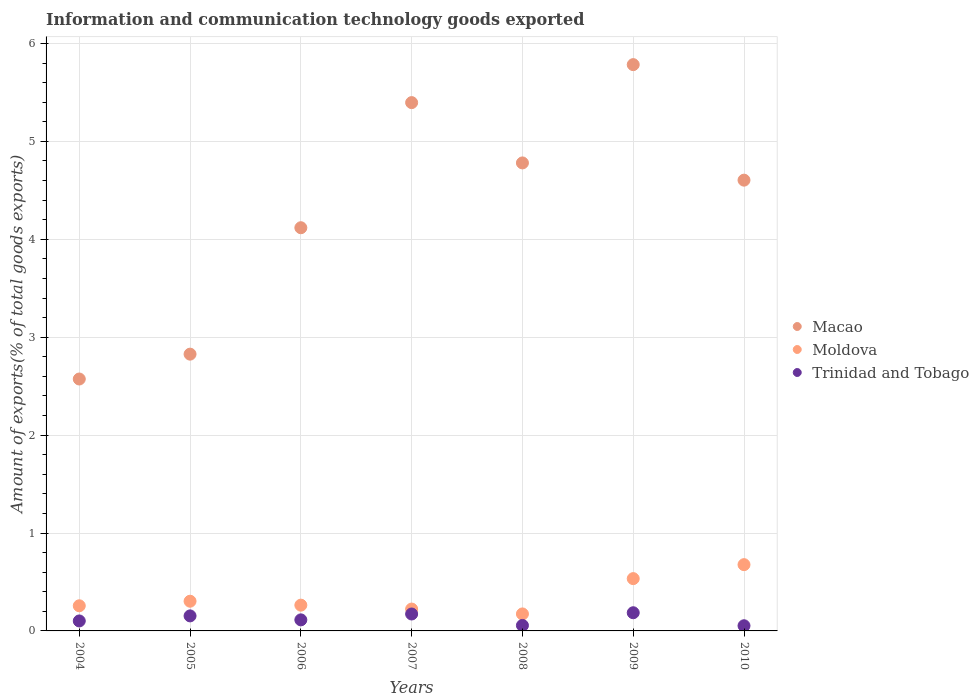What is the amount of goods exported in Macao in 2009?
Your response must be concise. 5.78. Across all years, what is the maximum amount of goods exported in Trinidad and Tobago?
Keep it short and to the point. 0.19. Across all years, what is the minimum amount of goods exported in Trinidad and Tobago?
Your answer should be very brief. 0.05. In which year was the amount of goods exported in Moldova maximum?
Ensure brevity in your answer.  2010. What is the total amount of goods exported in Moldova in the graph?
Ensure brevity in your answer.  2.43. What is the difference between the amount of goods exported in Macao in 2005 and that in 2009?
Provide a short and direct response. -2.96. What is the difference between the amount of goods exported in Macao in 2009 and the amount of goods exported in Moldova in 2008?
Ensure brevity in your answer.  5.61. What is the average amount of goods exported in Trinidad and Tobago per year?
Your answer should be compact. 0.12. In the year 2004, what is the difference between the amount of goods exported in Moldova and amount of goods exported in Trinidad and Tobago?
Your answer should be compact. 0.15. In how many years, is the amount of goods exported in Moldova greater than 2.6 %?
Make the answer very short. 0. What is the ratio of the amount of goods exported in Macao in 2007 to that in 2010?
Your answer should be very brief. 1.17. Is the amount of goods exported in Moldova in 2005 less than that in 2009?
Your answer should be very brief. Yes. Is the difference between the amount of goods exported in Moldova in 2004 and 2005 greater than the difference between the amount of goods exported in Trinidad and Tobago in 2004 and 2005?
Give a very brief answer. Yes. What is the difference between the highest and the second highest amount of goods exported in Trinidad and Tobago?
Your answer should be very brief. 0.01. What is the difference between the highest and the lowest amount of goods exported in Trinidad and Tobago?
Your answer should be compact. 0.13. In how many years, is the amount of goods exported in Macao greater than the average amount of goods exported in Macao taken over all years?
Make the answer very short. 4. Is the sum of the amount of goods exported in Trinidad and Tobago in 2005 and 2009 greater than the maximum amount of goods exported in Macao across all years?
Your response must be concise. No. Is it the case that in every year, the sum of the amount of goods exported in Macao and amount of goods exported in Moldova  is greater than the amount of goods exported in Trinidad and Tobago?
Make the answer very short. Yes. How many dotlines are there?
Make the answer very short. 3. How many years are there in the graph?
Keep it short and to the point. 7. Does the graph contain any zero values?
Keep it short and to the point. No. Does the graph contain grids?
Offer a very short reply. Yes. Where does the legend appear in the graph?
Make the answer very short. Center right. How are the legend labels stacked?
Provide a succinct answer. Vertical. What is the title of the graph?
Your response must be concise. Information and communication technology goods exported. Does "Colombia" appear as one of the legend labels in the graph?
Make the answer very short. No. What is the label or title of the X-axis?
Offer a terse response. Years. What is the label or title of the Y-axis?
Your answer should be very brief. Amount of exports(% of total goods exports). What is the Amount of exports(% of total goods exports) of Macao in 2004?
Keep it short and to the point. 2.57. What is the Amount of exports(% of total goods exports) of Moldova in 2004?
Provide a succinct answer. 0.26. What is the Amount of exports(% of total goods exports) in Trinidad and Tobago in 2004?
Keep it short and to the point. 0.1. What is the Amount of exports(% of total goods exports) of Macao in 2005?
Ensure brevity in your answer.  2.83. What is the Amount of exports(% of total goods exports) in Moldova in 2005?
Provide a succinct answer. 0.3. What is the Amount of exports(% of total goods exports) in Trinidad and Tobago in 2005?
Your answer should be very brief. 0.15. What is the Amount of exports(% of total goods exports) of Macao in 2006?
Your response must be concise. 4.12. What is the Amount of exports(% of total goods exports) in Moldova in 2006?
Provide a short and direct response. 0.26. What is the Amount of exports(% of total goods exports) in Trinidad and Tobago in 2006?
Give a very brief answer. 0.11. What is the Amount of exports(% of total goods exports) in Macao in 2007?
Provide a succinct answer. 5.4. What is the Amount of exports(% of total goods exports) in Moldova in 2007?
Ensure brevity in your answer.  0.22. What is the Amount of exports(% of total goods exports) of Trinidad and Tobago in 2007?
Offer a very short reply. 0.17. What is the Amount of exports(% of total goods exports) of Macao in 2008?
Give a very brief answer. 4.78. What is the Amount of exports(% of total goods exports) in Moldova in 2008?
Your answer should be very brief. 0.17. What is the Amount of exports(% of total goods exports) of Trinidad and Tobago in 2008?
Provide a short and direct response. 0.06. What is the Amount of exports(% of total goods exports) in Macao in 2009?
Your response must be concise. 5.78. What is the Amount of exports(% of total goods exports) in Moldova in 2009?
Your answer should be very brief. 0.53. What is the Amount of exports(% of total goods exports) in Trinidad and Tobago in 2009?
Provide a succinct answer. 0.19. What is the Amount of exports(% of total goods exports) of Macao in 2010?
Provide a short and direct response. 4.6. What is the Amount of exports(% of total goods exports) in Moldova in 2010?
Offer a very short reply. 0.68. What is the Amount of exports(% of total goods exports) in Trinidad and Tobago in 2010?
Give a very brief answer. 0.05. Across all years, what is the maximum Amount of exports(% of total goods exports) in Macao?
Make the answer very short. 5.78. Across all years, what is the maximum Amount of exports(% of total goods exports) of Moldova?
Your answer should be compact. 0.68. Across all years, what is the maximum Amount of exports(% of total goods exports) of Trinidad and Tobago?
Provide a short and direct response. 0.19. Across all years, what is the minimum Amount of exports(% of total goods exports) in Macao?
Make the answer very short. 2.57. Across all years, what is the minimum Amount of exports(% of total goods exports) of Moldova?
Provide a succinct answer. 0.17. Across all years, what is the minimum Amount of exports(% of total goods exports) in Trinidad and Tobago?
Make the answer very short. 0.05. What is the total Amount of exports(% of total goods exports) of Macao in the graph?
Provide a short and direct response. 30.08. What is the total Amount of exports(% of total goods exports) of Moldova in the graph?
Offer a terse response. 2.43. What is the total Amount of exports(% of total goods exports) of Trinidad and Tobago in the graph?
Your answer should be very brief. 0.84. What is the difference between the Amount of exports(% of total goods exports) of Macao in 2004 and that in 2005?
Keep it short and to the point. -0.25. What is the difference between the Amount of exports(% of total goods exports) in Moldova in 2004 and that in 2005?
Keep it short and to the point. -0.05. What is the difference between the Amount of exports(% of total goods exports) in Trinidad and Tobago in 2004 and that in 2005?
Your answer should be compact. -0.05. What is the difference between the Amount of exports(% of total goods exports) in Macao in 2004 and that in 2006?
Ensure brevity in your answer.  -1.55. What is the difference between the Amount of exports(% of total goods exports) in Moldova in 2004 and that in 2006?
Give a very brief answer. -0.01. What is the difference between the Amount of exports(% of total goods exports) of Trinidad and Tobago in 2004 and that in 2006?
Your answer should be very brief. -0.01. What is the difference between the Amount of exports(% of total goods exports) in Macao in 2004 and that in 2007?
Keep it short and to the point. -2.82. What is the difference between the Amount of exports(% of total goods exports) of Moldova in 2004 and that in 2007?
Keep it short and to the point. 0.03. What is the difference between the Amount of exports(% of total goods exports) of Trinidad and Tobago in 2004 and that in 2007?
Offer a very short reply. -0.07. What is the difference between the Amount of exports(% of total goods exports) of Macao in 2004 and that in 2008?
Give a very brief answer. -2.21. What is the difference between the Amount of exports(% of total goods exports) in Moldova in 2004 and that in 2008?
Your response must be concise. 0.08. What is the difference between the Amount of exports(% of total goods exports) of Trinidad and Tobago in 2004 and that in 2008?
Your answer should be very brief. 0.05. What is the difference between the Amount of exports(% of total goods exports) of Macao in 2004 and that in 2009?
Your response must be concise. -3.21. What is the difference between the Amount of exports(% of total goods exports) of Moldova in 2004 and that in 2009?
Ensure brevity in your answer.  -0.28. What is the difference between the Amount of exports(% of total goods exports) in Trinidad and Tobago in 2004 and that in 2009?
Your answer should be very brief. -0.08. What is the difference between the Amount of exports(% of total goods exports) in Macao in 2004 and that in 2010?
Offer a terse response. -2.03. What is the difference between the Amount of exports(% of total goods exports) in Moldova in 2004 and that in 2010?
Your answer should be very brief. -0.42. What is the difference between the Amount of exports(% of total goods exports) of Trinidad and Tobago in 2004 and that in 2010?
Make the answer very short. 0.05. What is the difference between the Amount of exports(% of total goods exports) of Macao in 2005 and that in 2006?
Your response must be concise. -1.29. What is the difference between the Amount of exports(% of total goods exports) of Moldova in 2005 and that in 2006?
Keep it short and to the point. 0.04. What is the difference between the Amount of exports(% of total goods exports) of Trinidad and Tobago in 2005 and that in 2006?
Offer a terse response. 0.04. What is the difference between the Amount of exports(% of total goods exports) of Macao in 2005 and that in 2007?
Provide a succinct answer. -2.57. What is the difference between the Amount of exports(% of total goods exports) in Moldova in 2005 and that in 2007?
Your answer should be very brief. 0.08. What is the difference between the Amount of exports(% of total goods exports) in Trinidad and Tobago in 2005 and that in 2007?
Your answer should be very brief. -0.02. What is the difference between the Amount of exports(% of total goods exports) in Macao in 2005 and that in 2008?
Offer a very short reply. -1.95. What is the difference between the Amount of exports(% of total goods exports) of Moldova in 2005 and that in 2008?
Offer a terse response. 0.13. What is the difference between the Amount of exports(% of total goods exports) in Trinidad and Tobago in 2005 and that in 2008?
Make the answer very short. 0.1. What is the difference between the Amount of exports(% of total goods exports) of Macao in 2005 and that in 2009?
Give a very brief answer. -2.96. What is the difference between the Amount of exports(% of total goods exports) in Moldova in 2005 and that in 2009?
Keep it short and to the point. -0.23. What is the difference between the Amount of exports(% of total goods exports) in Trinidad and Tobago in 2005 and that in 2009?
Offer a terse response. -0.03. What is the difference between the Amount of exports(% of total goods exports) in Macao in 2005 and that in 2010?
Your response must be concise. -1.78. What is the difference between the Amount of exports(% of total goods exports) of Moldova in 2005 and that in 2010?
Provide a succinct answer. -0.37. What is the difference between the Amount of exports(% of total goods exports) in Trinidad and Tobago in 2005 and that in 2010?
Provide a succinct answer. 0.1. What is the difference between the Amount of exports(% of total goods exports) in Macao in 2006 and that in 2007?
Your response must be concise. -1.28. What is the difference between the Amount of exports(% of total goods exports) of Moldova in 2006 and that in 2007?
Ensure brevity in your answer.  0.04. What is the difference between the Amount of exports(% of total goods exports) of Trinidad and Tobago in 2006 and that in 2007?
Your response must be concise. -0.06. What is the difference between the Amount of exports(% of total goods exports) in Macao in 2006 and that in 2008?
Provide a succinct answer. -0.66. What is the difference between the Amount of exports(% of total goods exports) in Moldova in 2006 and that in 2008?
Keep it short and to the point. 0.09. What is the difference between the Amount of exports(% of total goods exports) in Trinidad and Tobago in 2006 and that in 2008?
Your answer should be compact. 0.06. What is the difference between the Amount of exports(% of total goods exports) in Macao in 2006 and that in 2009?
Your answer should be compact. -1.67. What is the difference between the Amount of exports(% of total goods exports) of Moldova in 2006 and that in 2009?
Make the answer very short. -0.27. What is the difference between the Amount of exports(% of total goods exports) of Trinidad and Tobago in 2006 and that in 2009?
Ensure brevity in your answer.  -0.07. What is the difference between the Amount of exports(% of total goods exports) of Macao in 2006 and that in 2010?
Your response must be concise. -0.49. What is the difference between the Amount of exports(% of total goods exports) in Moldova in 2006 and that in 2010?
Your answer should be very brief. -0.41. What is the difference between the Amount of exports(% of total goods exports) of Trinidad and Tobago in 2006 and that in 2010?
Make the answer very short. 0.06. What is the difference between the Amount of exports(% of total goods exports) in Macao in 2007 and that in 2008?
Keep it short and to the point. 0.62. What is the difference between the Amount of exports(% of total goods exports) in Moldova in 2007 and that in 2008?
Make the answer very short. 0.05. What is the difference between the Amount of exports(% of total goods exports) of Trinidad and Tobago in 2007 and that in 2008?
Make the answer very short. 0.12. What is the difference between the Amount of exports(% of total goods exports) of Macao in 2007 and that in 2009?
Give a very brief answer. -0.39. What is the difference between the Amount of exports(% of total goods exports) of Moldova in 2007 and that in 2009?
Offer a terse response. -0.31. What is the difference between the Amount of exports(% of total goods exports) in Trinidad and Tobago in 2007 and that in 2009?
Offer a terse response. -0.01. What is the difference between the Amount of exports(% of total goods exports) in Macao in 2007 and that in 2010?
Ensure brevity in your answer.  0.79. What is the difference between the Amount of exports(% of total goods exports) of Moldova in 2007 and that in 2010?
Provide a short and direct response. -0.45. What is the difference between the Amount of exports(% of total goods exports) in Trinidad and Tobago in 2007 and that in 2010?
Offer a very short reply. 0.12. What is the difference between the Amount of exports(% of total goods exports) in Macao in 2008 and that in 2009?
Ensure brevity in your answer.  -1. What is the difference between the Amount of exports(% of total goods exports) of Moldova in 2008 and that in 2009?
Ensure brevity in your answer.  -0.36. What is the difference between the Amount of exports(% of total goods exports) of Trinidad and Tobago in 2008 and that in 2009?
Make the answer very short. -0.13. What is the difference between the Amount of exports(% of total goods exports) of Macao in 2008 and that in 2010?
Give a very brief answer. 0.18. What is the difference between the Amount of exports(% of total goods exports) in Moldova in 2008 and that in 2010?
Give a very brief answer. -0.5. What is the difference between the Amount of exports(% of total goods exports) of Trinidad and Tobago in 2008 and that in 2010?
Offer a very short reply. 0. What is the difference between the Amount of exports(% of total goods exports) of Macao in 2009 and that in 2010?
Offer a terse response. 1.18. What is the difference between the Amount of exports(% of total goods exports) of Moldova in 2009 and that in 2010?
Your answer should be very brief. -0.14. What is the difference between the Amount of exports(% of total goods exports) in Trinidad and Tobago in 2009 and that in 2010?
Provide a short and direct response. 0.13. What is the difference between the Amount of exports(% of total goods exports) of Macao in 2004 and the Amount of exports(% of total goods exports) of Moldova in 2005?
Keep it short and to the point. 2.27. What is the difference between the Amount of exports(% of total goods exports) in Macao in 2004 and the Amount of exports(% of total goods exports) in Trinidad and Tobago in 2005?
Your response must be concise. 2.42. What is the difference between the Amount of exports(% of total goods exports) in Moldova in 2004 and the Amount of exports(% of total goods exports) in Trinidad and Tobago in 2005?
Provide a succinct answer. 0.1. What is the difference between the Amount of exports(% of total goods exports) in Macao in 2004 and the Amount of exports(% of total goods exports) in Moldova in 2006?
Your answer should be very brief. 2.31. What is the difference between the Amount of exports(% of total goods exports) of Macao in 2004 and the Amount of exports(% of total goods exports) of Trinidad and Tobago in 2006?
Ensure brevity in your answer.  2.46. What is the difference between the Amount of exports(% of total goods exports) of Moldova in 2004 and the Amount of exports(% of total goods exports) of Trinidad and Tobago in 2006?
Provide a short and direct response. 0.14. What is the difference between the Amount of exports(% of total goods exports) of Macao in 2004 and the Amount of exports(% of total goods exports) of Moldova in 2007?
Give a very brief answer. 2.35. What is the difference between the Amount of exports(% of total goods exports) in Macao in 2004 and the Amount of exports(% of total goods exports) in Trinidad and Tobago in 2007?
Your answer should be compact. 2.4. What is the difference between the Amount of exports(% of total goods exports) in Moldova in 2004 and the Amount of exports(% of total goods exports) in Trinidad and Tobago in 2007?
Your answer should be compact. 0.08. What is the difference between the Amount of exports(% of total goods exports) in Macao in 2004 and the Amount of exports(% of total goods exports) in Moldova in 2008?
Keep it short and to the point. 2.4. What is the difference between the Amount of exports(% of total goods exports) in Macao in 2004 and the Amount of exports(% of total goods exports) in Trinidad and Tobago in 2008?
Make the answer very short. 2.52. What is the difference between the Amount of exports(% of total goods exports) of Moldova in 2004 and the Amount of exports(% of total goods exports) of Trinidad and Tobago in 2008?
Provide a short and direct response. 0.2. What is the difference between the Amount of exports(% of total goods exports) in Macao in 2004 and the Amount of exports(% of total goods exports) in Moldova in 2009?
Offer a very short reply. 2.04. What is the difference between the Amount of exports(% of total goods exports) of Macao in 2004 and the Amount of exports(% of total goods exports) of Trinidad and Tobago in 2009?
Make the answer very short. 2.39. What is the difference between the Amount of exports(% of total goods exports) of Moldova in 2004 and the Amount of exports(% of total goods exports) of Trinidad and Tobago in 2009?
Offer a very short reply. 0.07. What is the difference between the Amount of exports(% of total goods exports) of Macao in 2004 and the Amount of exports(% of total goods exports) of Moldova in 2010?
Ensure brevity in your answer.  1.9. What is the difference between the Amount of exports(% of total goods exports) in Macao in 2004 and the Amount of exports(% of total goods exports) in Trinidad and Tobago in 2010?
Your answer should be very brief. 2.52. What is the difference between the Amount of exports(% of total goods exports) in Moldova in 2004 and the Amount of exports(% of total goods exports) in Trinidad and Tobago in 2010?
Offer a terse response. 0.2. What is the difference between the Amount of exports(% of total goods exports) of Macao in 2005 and the Amount of exports(% of total goods exports) of Moldova in 2006?
Make the answer very short. 2.56. What is the difference between the Amount of exports(% of total goods exports) of Macao in 2005 and the Amount of exports(% of total goods exports) of Trinidad and Tobago in 2006?
Keep it short and to the point. 2.71. What is the difference between the Amount of exports(% of total goods exports) in Moldova in 2005 and the Amount of exports(% of total goods exports) in Trinidad and Tobago in 2006?
Make the answer very short. 0.19. What is the difference between the Amount of exports(% of total goods exports) of Macao in 2005 and the Amount of exports(% of total goods exports) of Moldova in 2007?
Keep it short and to the point. 2.6. What is the difference between the Amount of exports(% of total goods exports) of Macao in 2005 and the Amount of exports(% of total goods exports) of Trinidad and Tobago in 2007?
Offer a terse response. 2.65. What is the difference between the Amount of exports(% of total goods exports) in Moldova in 2005 and the Amount of exports(% of total goods exports) in Trinidad and Tobago in 2007?
Ensure brevity in your answer.  0.13. What is the difference between the Amount of exports(% of total goods exports) of Macao in 2005 and the Amount of exports(% of total goods exports) of Moldova in 2008?
Ensure brevity in your answer.  2.65. What is the difference between the Amount of exports(% of total goods exports) in Macao in 2005 and the Amount of exports(% of total goods exports) in Trinidad and Tobago in 2008?
Your response must be concise. 2.77. What is the difference between the Amount of exports(% of total goods exports) in Moldova in 2005 and the Amount of exports(% of total goods exports) in Trinidad and Tobago in 2008?
Provide a short and direct response. 0.25. What is the difference between the Amount of exports(% of total goods exports) in Macao in 2005 and the Amount of exports(% of total goods exports) in Moldova in 2009?
Offer a very short reply. 2.29. What is the difference between the Amount of exports(% of total goods exports) in Macao in 2005 and the Amount of exports(% of total goods exports) in Trinidad and Tobago in 2009?
Your answer should be very brief. 2.64. What is the difference between the Amount of exports(% of total goods exports) in Moldova in 2005 and the Amount of exports(% of total goods exports) in Trinidad and Tobago in 2009?
Offer a very short reply. 0.12. What is the difference between the Amount of exports(% of total goods exports) in Macao in 2005 and the Amount of exports(% of total goods exports) in Moldova in 2010?
Your answer should be compact. 2.15. What is the difference between the Amount of exports(% of total goods exports) in Macao in 2005 and the Amount of exports(% of total goods exports) in Trinidad and Tobago in 2010?
Give a very brief answer. 2.77. What is the difference between the Amount of exports(% of total goods exports) in Moldova in 2005 and the Amount of exports(% of total goods exports) in Trinidad and Tobago in 2010?
Provide a succinct answer. 0.25. What is the difference between the Amount of exports(% of total goods exports) of Macao in 2006 and the Amount of exports(% of total goods exports) of Moldova in 2007?
Make the answer very short. 3.89. What is the difference between the Amount of exports(% of total goods exports) of Macao in 2006 and the Amount of exports(% of total goods exports) of Trinidad and Tobago in 2007?
Your response must be concise. 3.95. What is the difference between the Amount of exports(% of total goods exports) of Moldova in 2006 and the Amount of exports(% of total goods exports) of Trinidad and Tobago in 2007?
Your response must be concise. 0.09. What is the difference between the Amount of exports(% of total goods exports) in Macao in 2006 and the Amount of exports(% of total goods exports) in Moldova in 2008?
Provide a short and direct response. 3.94. What is the difference between the Amount of exports(% of total goods exports) in Macao in 2006 and the Amount of exports(% of total goods exports) in Trinidad and Tobago in 2008?
Your answer should be very brief. 4.06. What is the difference between the Amount of exports(% of total goods exports) in Moldova in 2006 and the Amount of exports(% of total goods exports) in Trinidad and Tobago in 2008?
Your response must be concise. 0.21. What is the difference between the Amount of exports(% of total goods exports) of Macao in 2006 and the Amount of exports(% of total goods exports) of Moldova in 2009?
Offer a terse response. 3.58. What is the difference between the Amount of exports(% of total goods exports) of Macao in 2006 and the Amount of exports(% of total goods exports) of Trinidad and Tobago in 2009?
Keep it short and to the point. 3.93. What is the difference between the Amount of exports(% of total goods exports) of Moldova in 2006 and the Amount of exports(% of total goods exports) of Trinidad and Tobago in 2009?
Ensure brevity in your answer.  0.08. What is the difference between the Amount of exports(% of total goods exports) in Macao in 2006 and the Amount of exports(% of total goods exports) in Moldova in 2010?
Your answer should be compact. 3.44. What is the difference between the Amount of exports(% of total goods exports) in Macao in 2006 and the Amount of exports(% of total goods exports) in Trinidad and Tobago in 2010?
Make the answer very short. 4.07. What is the difference between the Amount of exports(% of total goods exports) in Moldova in 2006 and the Amount of exports(% of total goods exports) in Trinidad and Tobago in 2010?
Your answer should be compact. 0.21. What is the difference between the Amount of exports(% of total goods exports) of Macao in 2007 and the Amount of exports(% of total goods exports) of Moldova in 2008?
Ensure brevity in your answer.  5.22. What is the difference between the Amount of exports(% of total goods exports) of Macao in 2007 and the Amount of exports(% of total goods exports) of Trinidad and Tobago in 2008?
Provide a short and direct response. 5.34. What is the difference between the Amount of exports(% of total goods exports) in Moldova in 2007 and the Amount of exports(% of total goods exports) in Trinidad and Tobago in 2008?
Give a very brief answer. 0.17. What is the difference between the Amount of exports(% of total goods exports) of Macao in 2007 and the Amount of exports(% of total goods exports) of Moldova in 2009?
Make the answer very short. 4.86. What is the difference between the Amount of exports(% of total goods exports) in Macao in 2007 and the Amount of exports(% of total goods exports) in Trinidad and Tobago in 2009?
Provide a short and direct response. 5.21. What is the difference between the Amount of exports(% of total goods exports) of Moldova in 2007 and the Amount of exports(% of total goods exports) of Trinidad and Tobago in 2009?
Give a very brief answer. 0.04. What is the difference between the Amount of exports(% of total goods exports) of Macao in 2007 and the Amount of exports(% of total goods exports) of Moldova in 2010?
Keep it short and to the point. 4.72. What is the difference between the Amount of exports(% of total goods exports) of Macao in 2007 and the Amount of exports(% of total goods exports) of Trinidad and Tobago in 2010?
Your response must be concise. 5.34. What is the difference between the Amount of exports(% of total goods exports) of Moldova in 2007 and the Amount of exports(% of total goods exports) of Trinidad and Tobago in 2010?
Your answer should be compact. 0.17. What is the difference between the Amount of exports(% of total goods exports) of Macao in 2008 and the Amount of exports(% of total goods exports) of Moldova in 2009?
Provide a succinct answer. 4.25. What is the difference between the Amount of exports(% of total goods exports) in Macao in 2008 and the Amount of exports(% of total goods exports) in Trinidad and Tobago in 2009?
Give a very brief answer. 4.59. What is the difference between the Amount of exports(% of total goods exports) in Moldova in 2008 and the Amount of exports(% of total goods exports) in Trinidad and Tobago in 2009?
Give a very brief answer. -0.01. What is the difference between the Amount of exports(% of total goods exports) in Macao in 2008 and the Amount of exports(% of total goods exports) in Moldova in 2010?
Your answer should be compact. 4.1. What is the difference between the Amount of exports(% of total goods exports) of Macao in 2008 and the Amount of exports(% of total goods exports) of Trinidad and Tobago in 2010?
Your answer should be very brief. 4.73. What is the difference between the Amount of exports(% of total goods exports) in Moldova in 2008 and the Amount of exports(% of total goods exports) in Trinidad and Tobago in 2010?
Your answer should be very brief. 0.12. What is the difference between the Amount of exports(% of total goods exports) of Macao in 2009 and the Amount of exports(% of total goods exports) of Moldova in 2010?
Keep it short and to the point. 5.11. What is the difference between the Amount of exports(% of total goods exports) in Macao in 2009 and the Amount of exports(% of total goods exports) in Trinidad and Tobago in 2010?
Keep it short and to the point. 5.73. What is the difference between the Amount of exports(% of total goods exports) in Moldova in 2009 and the Amount of exports(% of total goods exports) in Trinidad and Tobago in 2010?
Give a very brief answer. 0.48. What is the average Amount of exports(% of total goods exports) of Macao per year?
Your answer should be very brief. 4.3. What is the average Amount of exports(% of total goods exports) in Moldova per year?
Make the answer very short. 0.35. What is the average Amount of exports(% of total goods exports) in Trinidad and Tobago per year?
Offer a terse response. 0.12. In the year 2004, what is the difference between the Amount of exports(% of total goods exports) in Macao and Amount of exports(% of total goods exports) in Moldova?
Your response must be concise. 2.32. In the year 2004, what is the difference between the Amount of exports(% of total goods exports) of Macao and Amount of exports(% of total goods exports) of Trinidad and Tobago?
Offer a very short reply. 2.47. In the year 2004, what is the difference between the Amount of exports(% of total goods exports) in Moldova and Amount of exports(% of total goods exports) in Trinidad and Tobago?
Make the answer very short. 0.15. In the year 2005, what is the difference between the Amount of exports(% of total goods exports) of Macao and Amount of exports(% of total goods exports) of Moldova?
Give a very brief answer. 2.52. In the year 2005, what is the difference between the Amount of exports(% of total goods exports) of Macao and Amount of exports(% of total goods exports) of Trinidad and Tobago?
Your answer should be compact. 2.67. In the year 2005, what is the difference between the Amount of exports(% of total goods exports) in Moldova and Amount of exports(% of total goods exports) in Trinidad and Tobago?
Provide a succinct answer. 0.15. In the year 2006, what is the difference between the Amount of exports(% of total goods exports) of Macao and Amount of exports(% of total goods exports) of Moldova?
Keep it short and to the point. 3.85. In the year 2006, what is the difference between the Amount of exports(% of total goods exports) in Macao and Amount of exports(% of total goods exports) in Trinidad and Tobago?
Your response must be concise. 4.01. In the year 2006, what is the difference between the Amount of exports(% of total goods exports) in Moldova and Amount of exports(% of total goods exports) in Trinidad and Tobago?
Ensure brevity in your answer.  0.15. In the year 2007, what is the difference between the Amount of exports(% of total goods exports) of Macao and Amount of exports(% of total goods exports) of Moldova?
Your answer should be very brief. 5.17. In the year 2007, what is the difference between the Amount of exports(% of total goods exports) in Macao and Amount of exports(% of total goods exports) in Trinidad and Tobago?
Offer a terse response. 5.22. In the year 2007, what is the difference between the Amount of exports(% of total goods exports) of Moldova and Amount of exports(% of total goods exports) of Trinidad and Tobago?
Give a very brief answer. 0.05. In the year 2008, what is the difference between the Amount of exports(% of total goods exports) of Macao and Amount of exports(% of total goods exports) of Moldova?
Make the answer very short. 4.61. In the year 2008, what is the difference between the Amount of exports(% of total goods exports) of Macao and Amount of exports(% of total goods exports) of Trinidad and Tobago?
Offer a very short reply. 4.72. In the year 2008, what is the difference between the Amount of exports(% of total goods exports) in Moldova and Amount of exports(% of total goods exports) in Trinidad and Tobago?
Provide a succinct answer. 0.12. In the year 2009, what is the difference between the Amount of exports(% of total goods exports) in Macao and Amount of exports(% of total goods exports) in Moldova?
Give a very brief answer. 5.25. In the year 2009, what is the difference between the Amount of exports(% of total goods exports) of Macao and Amount of exports(% of total goods exports) of Trinidad and Tobago?
Provide a succinct answer. 5.6. In the year 2009, what is the difference between the Amount of exports(% of total goods exports) in Moldova and Amount of exports(% of total goods exports) in Trinidad and Tobago?
Your answer should be very brief. 0.35. In the year 2010, what is the difference between the Amount of exports(% of total goods exports) in Macao and Amount of exports(% of total goods exports) in Moldova?
Provide a short and direct response. 3.93. In the year 2010, what is the difference between the Amount of exports(% of total goods exports) in Macao and Amount of exports(% of total goods exports) in Trinidad and Tobago?
Keep it short and to the point. 4.55. In the year 2010, what is the difference between the Amount of exports(% of total goods exports) of Moldova and Amount of exports(% of total goods exports) of Trinidad and Tobago?
Make the answer very short. 0.62. What is the ratio of the Amount of exports(% of total goods exports) of Macao in 2004 to that in 2005?
Keep it short and to the point. 0.91. What is the ratio of the Amount of exports(% of total goods exports) in Moldova in 2004 to that in 2005?
Offer a terse response. 0.85. What is the ratio of the Amount of exports(% of total goods exports) of Trinidad and Tobago in 2004 to that in 2005?
Provide a short and direct response. 0.66. What is the ratio of the Amount of exports(% of total goods exports) in Macao in 2004 to that in 2006?
Keep it short and to the point. 0.62. What is the ratio of the Amount of exports(% of total goods exports) of Moldova in 2004 to that in 2006?
Your answer should be compact. 0.98. What is the ratio of the Amount of exports(% of total goods exports) of Trinidad and Tobago in 2004 to that in 2006?
Ensure brevity in your answer.  0.9. What is the ratio of the Amount of exports(% of total goods exports) of Macao in 2004 to that in 2007?
Your response must be concise. 0.48. What is the ratio of the Amount of exports(% of total goods exports) of Moldova in 2004 to that in 2007?
Provide a succinct answer. 1.15. What is the ratio of the Amount of exports(% of total goods exports) of Trinidad and Tobago in 2004 to that in 2007?
Keep it short and to the point. 0.59. What is the ratio of the Amount of exports(% of total goods exports) in Macao in 2004 to that in 2008?
Your answer should be compact. 0.54. What is the ratio of the Amount of exports(% of total goods exports) in Moldova in 2004 to that in 2008?
Provide a succinct answer. 1.48. What is the ratio of the Amount of exports(% of total goods exports) of Trinidad and Tobago in 2004 to that in 2008?
Your answer should be compact. 1.82. What is the ratio of the Amount of exports(% of total goods exports) of Macao in 2004 to that in 2009?
Provide a short and direct response. 0.44. What is the ratio of the Amount of exports(% of total goods exports) in Moldova in 2004 to that in 2009?
Offer a terse response. 0.48. What is the ratio of the Amount of exports(% of total goods exports) in Trinidad and Tobago in 2004 to that in 2009?
Make the answer very short. 0.55. What is the ratio of the Amount of exports(% of total goods exports) in Macao in 2004 to that in 2010?
Offer a very short reply. 0.56. What is the ratio of the Amount of exports(% of total goods exports) of Moldova in 2004 to that in 2010?
Give a very brief answer. 0.38. What is the ratio of the Amount of exports(% of total goods exports) in Trinidad and Tobago in 2004 to that in 2010?
Your response must be concise. 1.93. What is the ratio of the Amount of exports(% of total goods exports) of Macao in 2005 to that in 2006?
Provide a short and direct response. 0.69. What is the ratio of the Amount of exports(% of total goods exports) of Moldova in 2005 to that in 2006?
Provide a short and direct response. 1.15. What is the ratio of the Amount of exports(% of total goods exports) of Trinidad and Tobago in 2005 to that in 2006?
Give a very brief answer. 1.36. What is the ratio of the Amount of exports(% of total goods exports) of Macao in 2005 to that in 2007?
Your response must be concise. 0.52. What is the ratio of the Amount of exports(% of total goods exports) of Moldova in 2005 to that in 2007?
Your answer should be very brief. 1.36. What is the ratio of the Amount of exports(% of total goods exports) in Trinidad and Tobago in 2005 to that in 2007?
Ensure brevity in your answer.  0.89. What is the ratio of the Amount of exports(% of total goods exports) in Macao in 2005 to that in 2008?
Offer a terse response. 0.59. What is the ratio of the Amount of exports(% of total goods exports) in Moldova in 2005 to that in 2008?
Keep it short and to the point. 1.75. What is the ratio of the Amount of exports(% of total goods exports) of Trinidad and Tobago in 2005 to that in 2008?
Offer a terse response. 2.74. What is the ratio of the Amount of exports(% of total goods exports) of Macao in 2005 to that in 2009?
Your response must be concise. 0.49. What is the ratio of the Amount of exports(% of total goods exports) in Moldova in 2005 to that in 2009?
Provide a succinct answer. 0.57. What is the ratio of the Amount of exports(% of total goods exports) of Trinidad and Tobago in 2005 to that in 2009?
Your response must be concise. 0.83. What is the ratio of the Amount of exports(% of total goods exports) in Macao in 2005 to that in 2010?
Provide a short and direct response. 0.61. What is the ratio of the Amount of exports(% of total goods exports) in Moldova in 2005 to that in 2010?
Give a very brief answer. 0.45. What is the ratio of the Amount of exports(% of total goods exports) in Trinidad and Tobago in 2005 to that in 2010?
Keep it short and to the point. 2.91. What is the ratio of the Amount of exports(% of total goods exports) of Macao in 2006 to that in 2007?
Provide a succinct answer. 0.76. What is the ratio of the Amount of exports(% of total goods exports) in Moldova in 2006 to that in 2007?
Your answer should be very brief. 1.18. What is the ratio of the Amount of exports(% of total goods exports) in Trinidad and Tobago in 2006 to that in 2007?
Give a very brief answer. 0.65. What is the ratio of the Amount of exports(% of total goods exports) in Macao in 2006 to that in 2008?
Provide a short and direct response. 0.86. What is the ratio of the Amount of exports(% of total goods exports) in Moldova in 2006 to that in 2008?
Give a very brief answer. 1.52. What is the ratio of the Amount of exports(% of total goods exports) of Trinidad and Tobago in 2006 to that in 2008?
Ensure brevity in your answer.  2.02. What is the ratio of the Amount of exports(% of total goods exports) of Macao in 2006 to that in 2009?
Make the answer very short. 0.71. What is the ratio of the Amount of exports(% of total goods exports) in Moldova in 2006 to that in 2009?
Provide a succinct answer. 0.49. What is the ratio of the Amount of exports(% of total goods exports) in Trinidad and Tobago in 2006 to that in 2009?
Ensure brevity in your answer.  0.61. What is the ratio of the Amount of exports(% of total goods exports) in Macao in 2006 to that in 2010?
Give a very brief answer. 0.89. What is the ratio of the Amount of exports(% of total goods exports) of Moldova in 2006 to that in 2010?
Provide a short and direct response. 0.39. What is the ratio of the Amount of exports(% of total goods exports) of Trinidad and Tobago in 2006 to that in 2010?
Your answer should be very brief. 2.14. What is the ratio of the Amount of exports(% of total goods exports) in Macao in 2007 to that in 2008?
Ensure brevity in your answer.  1.13. What is the ratio of the Amount of exports(% of total goods exports) in Moldova in 2007 to that in 2008?
Provide a succinct answer. 1.29. What is the ratio of the Amount of exports(% of total goods exports) of Trinidad and Tobago in 2007 to that in 2008?
Your response must be concise. 3.09. What is the ratio of the Amount of exports(% of total goods exports) in Macao in 2007 to that in 2009?
Make the answer very short. 0.93. What is the ratio of the Amount of exports(% of total goods exports) of Moldova in 2007 to that in 2009?
Offer a very short reply. 0.42. What is the ratio of the Amount of exports(% of total goods exports) in Macao in 2007 to that in 2010?
Your response must be concise. 1.17. What is the ratio of the Amount of exports(% of total goods exports) of Moldova in 2007 to that in 2010?
Offer a terse response. 0.33. What is the ratio of the Amount of exports(% of total goods exports) of Trinidad and Tobago in 2007 to that in 2010?
Make the answer very short. 3.28. What is the ratio of the Amount of exports(% of total goods exports) of Macao in 2008 to that in 2009?
Your answer should be very brief. 0.83. What is the ratio of the Amount of exports(% of total goods exports) of Moldova in 2008 to that in 2009?
Keep it short and to the point. 0.32. What is the ratio of the Amount of exports(% of total goods exports) of Trinidad and Tobago in 2008 to that in 2009?
Make the answer very short. 0.3. What is the ratio of the Amount of exports(% of total goods exports) in Macao in 2008 to that in 2010?
Your answer should be compact. 1.04. What is the ratio of the Amount of exports(% of total goods exports) in Moldova in 2008 to that in 2010?
Provide a short and direct response. 0.26. What is the ratio of the Amount of exports(% of total goods exports) in Trinidad and Tobago in 2008 to that in 2010?
Keep it short and to the point. 1.06. What is the ratio of the Amount of exports(% of total goods exports) of Macao in 2009 to that in 2010?
Offer a very short reply. 1.26. What is the ratio of the Amount of exports(% of total goods exports) of Moldova in 2009 to that in 2010?
Make the answer very short. 0.79. What is the ratio of the Amount of exports(% of total goods exports) in Trinidad and Tobago in 2009 to that in 2010?
Your answer should be very brief. 3.52. What is the difference between the highest and the second highest Amount of exports(% of total goods exports) in Macao?
Your answer should be compact. 0.39. What is the difference between the highest and the second highest Amount of exports(% of total goods exports) of Moldova?
Your answer should be very brief. 0.14. What is the difference between the highest and the second highest Amount of exports(% of total goods exports) in Trinidad and Tobago?
Provide a short and direct response. 0.01. What is the difference between the highest and the lowest Amount of exports(% of total goods exports) of Macao?
Offer a very short reply. 3.21. What is the difference between the highest and the lowest Amount of exports(% of total goods exports) in Moldova?
Offer a very short reply. 0.5. What is the difference between the highest and the lowest Amount of exports(% of total goods exports) in Trinidad and Tobago?
Provide a short and direct response. 0.13. 